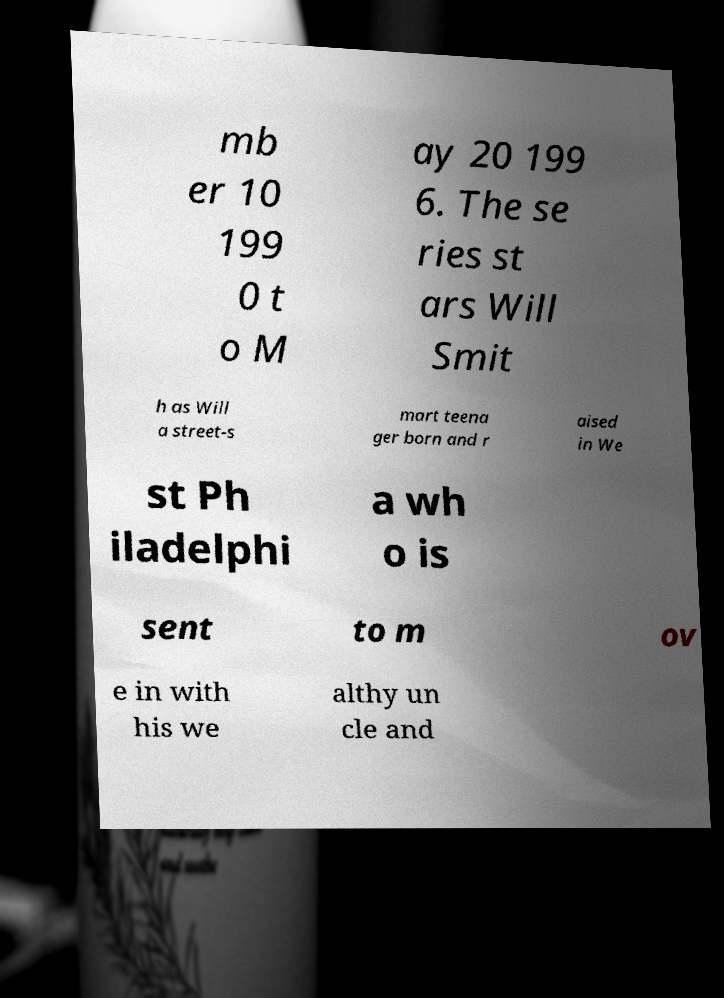What messages or text are displayed in this image? I need them in a readable, typed format. mb er 10 199 0 t o M ay 20 199 6. The se ries st ars Will Smit h as Will a street-s mart teena ger born and r aised in We st Ph iladelphi a wh o is sent to m ov e in with his we althy un cle and 